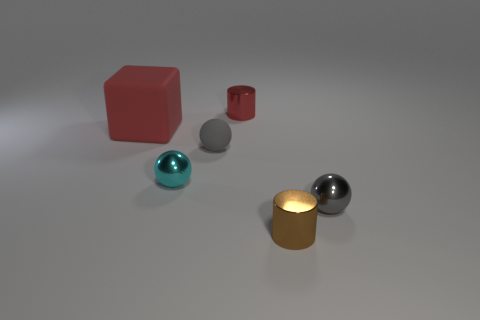Is there any other thing that has the same size as the red matte block?
Give a very brief answer. No. There is another small ball that is the same material as the cyan ball; what color is it?
Give a very brief answer. Gray. How many brown cylinders have the same material as the cyan thing?
Provide a short and direct response. 1. There is a tiny matte thing; is it the same color as the metallic cylinder behind the brown shiny cylinder?
Provide a short and direct response. No. What is the color of the metallic cylinder to the right of the small metal cylinder behind the big red rubber block?
Provide a succinct answer. Brown. What color is the other metallic cylinder that is the same size as the brown shiny cylinder?
Ensure brevity in your answer.  Red. Are there any tiny gray rubber objects of the same shape as the tiny cyan metallic object?
Make the answer very short. Yes. What is the shape of the tiny red metal thing?
Your answer should be very brief. Cylinder. Are there more matte blocks on the right side of the red shiny cylinder than tiny cyan spheres behind the small brown metallic cylinder?
Your answer should be very brief. No. What number of other things are there of the same size as the matte ball?
Your answer should be compact. 4. 